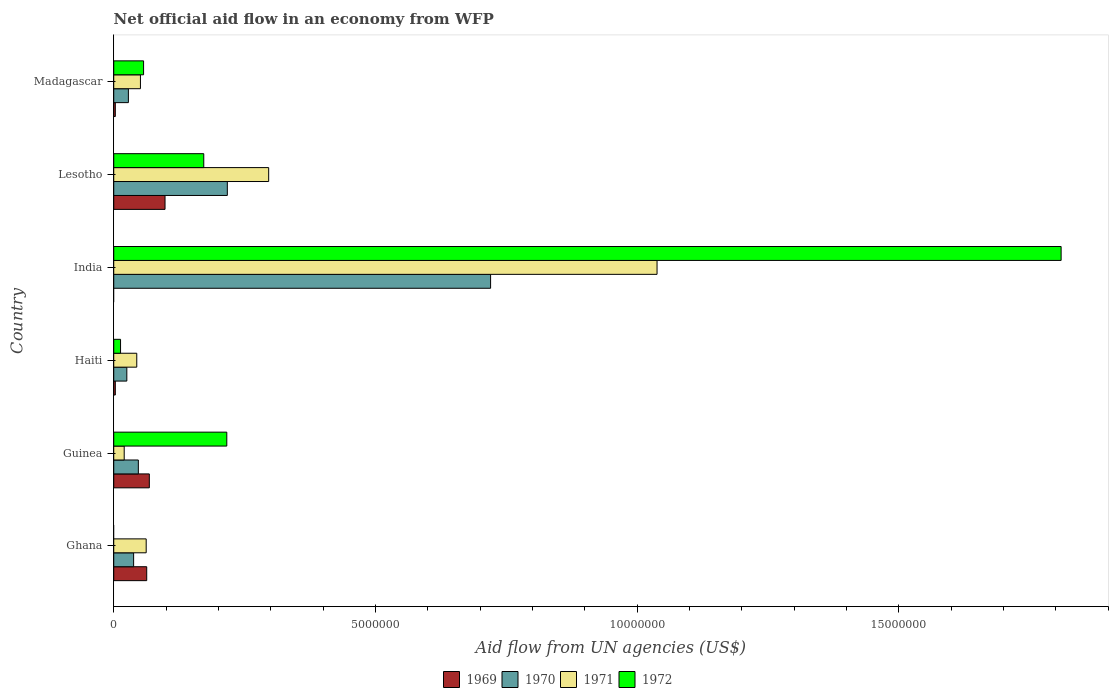How many groups of bars are there?
Offer a very short reply. 6. Are the number of bars per tick equal to the number of legend labels?
Give a very brief answer. No. How many bars are there on the 2nd tick from the top?
Your answer should be compact. 4. How many bars are there on the 3rd tick from the bottom?
Give a very brief answer. 4. What is the label of the 3rd group of bars from the top?
Provide a succinct answer. India. What is the net official aid flow in 1972 in Lesotho?
Make the answer very short. 1.72e+06. Across all countries, what is the maximum net official aid flow in 1972?
Your answer should be very brief. 1.81e+07. What is the total net official aid flow in 1971 in the graph?
Provide a short and direct response. 1.51e+07. What is the average net official aid flow in 1970 per country?
Your response must be concise. 1.79e+06. What is the difference between the net official aid flow in 1969 and net official aid flow in 1970 in Guinea?
Keep it short and to the point. 2.10e+05. In how many countries, is the net official aid flow in 1969 greater than 11000000 US$?
Your answer should be very brief. 0. What is the ratio of the net official aid flow in 1970 in Guinea to that in India?
Provide a succinct answer. 0.07. Is the difference between the net official aid flow in 1969 in Ghana and Guinea greater than the difference between the net official aid flow in 1970 in Ghana and Guinea?
Provide a short and direct response. Yes. What is the difference between the highest and the second highest net official aid flow in 1972?
Keep it short and to the point. 1.59e+07. What is the difference between the highest and the lowest net official aid flow in 1969?
Ensure brevity in your answer.  9.80e+05. How many bars are there?
Make the answer very short. 22. What is the difference between two consecutive major ticks on the X-axis?
Keep it short and to the point. 5.00e+06. Does the graph contain any zero values?
Ensure brevity in your answer.  Yes. How many legend labels are there?
Provide a short and direct response. 4. How are the legend labels stacked?
Provide a succinct answer. Horizontal. What is the title of the graph?
Give a very brief answer. Net official aid flow in an economy from WFP. What is the label or title of the X-axis?
Offer a terse response. Aid flow from UN agencies (US$). What is the Aid flow from UN agencies (US$) in 1969 in Ghana?
Your response must be concise. 6.30e+05. What is the Aid flow from UN agencies (US$) in 1970 in Ghana?
Make the answer very short. 3.80e+05. What is the Aid flow from UN agencies (US$) of 1971 in Ghana?
Your response must be concise. 6.20e+05. What is the Aid flow from UN agencies (US$) in 1972 in Ghana?
Provide a succinct answer. 0. What is the Aid flow from UN agencies (US$) of 1969 in Guinea?
Offer a very short reply. 6.80e+05. What is the Aid flow from UN agencies (US$) in 1970 in Guinea?
Your answer should be very brief. 4.70e+05. What is the Aid flow from UN agencies (US$) of 1972 in Guinea?
Your response must be concise. 2.16e+06. What is the Aid flow from UN agencies (US$) in 1969 in Haiti?
Offer a terse response. 3.00e+04. What is the Aid flow from UN agencies (US$) in 1970 in India?
Keep it short and to the point. 7.20e+06. What is the Aid flow from UN agencies (US$) in 1971 in India?
Ensure brevity in your answer.  1.04e+07. What is the Aid flow from UN agencies (US$) in 1972 in India?
Give a very brief answer. 1.81e+07. What is the Aid flow from UN agencies (US$) of 1969 in Lesotho?
Your response must be concise. 9.80e+05. What is the Aid flow from UN agencies (US$) in 1970 in Lesotho?
Offer a terse response. 2.17e+06. What is the Aid flow from UN agencies (US$) in 1971 in Lesotho?
Provide a succinct answer. 2.96e+06. What is the Aid flow from UN agencies (US$) in 1972 in Lesotho?
Give a very brief answer. 1.72e+06. What is the Aid flow from UN agencies (US$) in 1969 in Madagascar?
Make the answer very short. 3.00e+04. What is the Aid flow from UN agencies (US$) in 1971 in Madagascar?
Your answer should be very brief. 5.10e+05. What is the Aid flow from UN agencies (US$) of 1972 in Madagascar?
Keep it short and to the point. 5.70e+05. Across all countries, what is the maximum Aid flow from UN agencies (US$) of 1969?
Provide a succinct answer. 9.80e+05. Across all countries, what is the maximum Aid flow from UN agencies (US$) in 1970?
Your response must be concise. 7.20e+06. Across all countries, what is the maximum Aid flow from UN agencies (US$) in 1971?
Your answer should be very brief. 1.04e+07. Across all countries, what is the maximum Aid flow from UN agencies (US$) in 1972?
Offer a very short reply. 1.81e+07. Across all countries, what is the minimum Aid flow from UN agencies (US$) in 1969?
Ensure brevity in your answer.  0. Across all countries, what is the minimum Aid flow from UN agencies (US$) of 1970?
Make the answer very short. 2.50e+05. Across all countries, what is the minimum Aid flow from UN agencies (US$) of 1971?
Keep it short and to the point. 2.00e+05. Across all countries, what is the minimum Aid flow from UN agencies (US$) of 1972?
Your answer should be compact. 0. What is the total Aid flow from UN agencies (US$) in 1969 in the graph?
Offer a terse response. 2.35e+06. What is the total Aid flow from UN agencies (US$) in 1970 in the graph?
Offer a terse response. 1.08e+07. What is the total Aid flow from UN agencies (US$) of 1971 in the graph?
Your response must be concise. 1.51e+07. What is the total Aid flow from UN agencies (US$) of 1972 in the graph?
Ensure brevity in your answer.  2.27e+07. What is the difference between the Aid flow from UN agencies (US$) of 1969 in Ghana and that in Guinea?
Offer a very short reply. -5.00e+04. What is the difference between the Aid flow from UN agencies (US$) in 1969 in Ghana and that in Haiti?
Offer a very short reply. 6.00e+05. What is the difference between the Aid flow from UN agencies (US$) of 1970 in Ghana and that in Haiti?
Your answer should be compact. 1.30e+05. What is the difference between the Aid flow from UN agencies (US$) of 1971 in Ghana and that in Haiti?
Offer a very short reply. 1.80e+05. What is the difference between the Aid flow from UN agencies (US$) of 1970 in Ghana and that in India?
Ensure brevity in your answer.  -6.82e+06. What is the difference between the Aid flow from UN agencies (US$) in 1971 in Ghana and that in India?
Your answer should be very brief. -9.76e+06. What is the difference between the Aid flow from UN agencies (US$) of 1969 in Ghana and that in Lesotho?
Provide a short and direct response. -3.50e+05. What is the difference between the Aid flow from UN agencies (US$) in 1970 in Ghana and that in Lesotho?
Ensure brevity in your answer.  -1.79e+06. What is the difference between the Aid flow from UN agencies (US$) of 1971 in Ghana and that in Lesotho?
Your response must be concise. -2.34e+06. What is the difference between the Aid flow from UN agencies (US$) in 1969 in Guinea and that in Haiti?
Make the answer very short. 6.50e+05. What is the difference between the Aid flow from UN agencies (US$) of 1970 in Guinea and that in Haiti?
Give a very brief answer. 2.20e+05. What is the difference between the Aid flow from UN agencies (US$) of 1972 in Guinea and that in Haiti?
Your answer should be compact. 2.03e+06. What is the difference between the Aid flow from UN agencies (US$) in 1970 in Guinea and that in India?
Offer a terse response. -6.73e+06. What is the difference between the Aid flow from UN agencies (US$) of 1971 in Guinea and that in India?
Give a very brief answer. -1.02e+07. What is the difference between the Aid flow from UN agencies (US$) of 1972 in Guinea and that in India?
Your answer should be very brief. -1.59e+07. What is the difference between the Aid flow from UN agencies (US$) in 1969 in Guinea and that in Lesotho?
Keep it short and to the point. -3.00e+05. What is the difference between the Aid flow from UN agencies (US$) of 1970 in Guinea and that in Lesotho?
Your response must be concise. -1.70e+06. What is the difference between the Aid flow from UN agencies (US$) in 1971 in Guinea and that in Lesotho?
Keep it short and to the point. -2.76e+06. What is the difference between the Aid flow from UN agencies (US$) of 1969 in Guinea and that in Madagascar?
Offer a terse response. 6.50e+05. What is the difference between the Aid flow from UN agencies (US$) in 1970 in Guinea and that in Madagascar?
Provide a short and direct response. 1.90e+05. What is the difference between the Aid flow from UN agencies (US$) in 1971 in Guinea and that in Madagascar?
Your answer should be compact. -3.10e+05. What is the difference between the Aid flow from UN agencies (US$) of 1972 in Guinea and that in Madagascar?
Your response must be concise. 1.59e+06. What is the difference between the Aid flow from UN agencies (US$) of 1970 in Haiti and that in India?
Make the answer very short. -6.95e+06. What is the difference between the Aid flow from UN agencies (US$) of 1971 in Haiti and that in India?
Provide a short and direct response. -9.94e+06. What is the difference between the Aid flow from UN agencies (US$) of 1972 in Haiti and that in India?
Offer a terse response. -1.80e+07. What is the difference between the Aid flow from UN agencies (US$) in 1969 in Haiti and that in Lesotho?
Ensure brevity in your answer.  -9.50e+05. What is the difference between the Aid flow from UN agencies (US$) in 1970 in Haiti and that in Lesotho?
Your response must be concise. -1.92e+06. What is the difference between the Aid flow from UN agencies (US$) of 1971 in Haiti and that in Lesotho?
Give a very brief answer. -2.52e+06. What is the difference between the Aid flow from UN agencies (US$) of 1972 in Haiti and that in Lesotho?
Offer a very short reply. -1.59e+06. What is the difference between the Aid flow from UN agencies (US$) in 1970 in Haiti and that in Madagascar?
Offer a very short reply. -3.00e+04. What is the difference between the Aid flow from UN agencies (US$) in 1971 in Haiti and that in Madagascar?
Provide a short and direct response. -7.00e+04. What is the difference between the Aid flow from UN agencies (US$) of 1972 in Haiti and that in Madagascar?
Your response must be concise. -4.40e+05. What is the difference between the Aid flow from UN agencies (US$) in 1970 in India and that in Lesotho?
Ensure brevity in your answer.  5.03e+06. What is the difference between the Aid flow from UN agencies (US$) of 1971 in India and that in Lesotho?
Provide a short and direct response. 7.42e+06. What is the difference between the Aid flow from UN agencies (US$) in 1972 in India and that in Lesotho?
Your answer should be very brief. 1.64e+07. What is the difference between the Aid flow from UN agencies (US$) of 1970 in India and that in Madagascar?
Offer a very short reply. 6.92e+06. What is the difference between the Aid flow from UN agencies (US$) in 1971 in India and that in Madagascar?
Your answer should be very brief. 9.87e+06. What is the difference between the Aid flow from UN agencies (US$) of 1972 in India and that in Madagascar?
Provide a succinct answer. 1.75e+07. What is the difference between the Aid flow from UN agencies (US$) in 1969 in Lesotho and that in Madagascar?
Keep it short and to the point. 9.50e+05. What is the difference between the Aid flow from UN agencies (US$) of 1970 in Lesotho and that in Madagascar?
Give a very brief answer. 1.89e+06. What is the difference between the Aid flow from UN agencies (US$) in 1971 in Lesotho and that in Madagascar?
Offer a very short reply. 2.45e+06. What is the difference between the Aid flow from UN agencies (US$) in 1972 in Lesotho and that in Madagascar?
Your answer should be very brief. 1.15e+06. What is the difference between the Aid flow from UN agencies (US$) in 1969 in Ghana and the Aid flow from UN agencies (US$) in 1970 in Guinea?
Your answer should be compact. 1.60e+05. What is the difference between the Aid flow from UN agencies (US$) of 1969 in Ghana and the Aid flow from UN agencies (US$) of 1972 in Guinea?
Provide a short and direct response. -1.53e+06. What is the difference between the Aid flow from UN agencies (US$) of 1970 in Ghana and the Aid flow from UN agencies (US$) of 1972 in Guinea?
Offer a terse response. -1.78e+06. What is the difference between the Aid flow from UN agencies (US$) in 1971 in Ghana and the Aid flow from UN agencies (US$) in 1972 in Guinea?
Make the answer very short. -1.54e+06. What is the difference between the Aid flow from UN agencies (US$) of 1969 in Ghana and the Aid flow from UN agencies (US$) of 1970 in Haiti?
Offer a very short reply. 3.80e+05. What is the difference between the Aid flow from UN agencies (US$) in 1969 in Ghana and the Aid flow from UN agencies (US$) in 1972 in Haiti?
Give a very brief answer. 5.00e+05. What is the difference between the Aid flow from UN agencies (US$) of 1969 in Ghana and the Aid flow from UN agencies (US$) of 1970 in India?
Your response must be concise. -6.57e+06. What is the difference between the Aid flow from UN agencies (US$) in 1969 in Ghana and the Aid flow from UN agencies (US$) in 1971 in India?
Ensure brevity in your answer.  -9.75e+06. What is the difference between the Aid flow from UN agencies (US$) of 1969 in Ghana and the Aid flow from UN agencies (US$) of 1972 in India?
Ensure brevity in your answer.  -1.75e+07. What is the difference between the Aid flow from UN agencies (US$) in 1970 in Ghana and the Aid flow from UN agencies (US$) in 1971 in India?
Keep it short and to the point. -1.00e+07. What is the difference between the Aid flow from UN agencies (US$) of 1970 in Ghana and the Aid flow from UN agencies (US$) of 1972 in India?
Your response must be concise. -1.77e+07. What is the difference between the Aid flow from UN agencies (US$) in 1971 in Ghana and the Aid flow from UN agencies (US$) in 1972 in India?
Keep it short and to the point. -1.75e+07. What is the difference between the Aid flow from UN agencies (US$) in 1969 in Ghana and the Aid flow from UN agencies (US$) in 1970 in Lesotho?
Make the answer very short. -1.54e+06. What is the difference between the Aid flow from UN agencies (US$) in 1969 in Ghana and the Aid flow from UN agencies (US$) in 1971 in Lesotho?
Your response must be concise. -2.33e+06. What is the difference between the Aid flow from UN agencies (US$) in 1969 in Ghana and the Aid flow from UN agencies (US$) in 1972 in Lesotho?
Your answer should be very brief. -1.09e+06. What is the difference between the Aid flow from UN agencies (US$) of 1970 in Ghana and the Aid flow from UN agencies (US$) of 1971 in Lesotho?
Provide a short and direct response. -2.58e+06. What is the difference between the Aid flow from UN agencies (US$) of 1970 in Ghana and the Aid flow from UN agencies (US$) of 1972 in Lesotho?
Ensure brevity in your answer.  -1.34e+06. What is the difference between the Aid flow from UN agencies (US$) in 1971 in Ghana and the Aid flow from UN agencies (US$) in 1972 in Lesotho?
Your answer should be very brief. -1.10e+06. What is the difference between the Aid flow from UN agencies (US$) in 1969 in Ghana and the Aid flow from UN agencies (US$) in 1971 in Madagascar?
Offer a very short reply. 1.20e+05. What is the difference between the Aid flow from UN agencies (US$) in 1969 in Ghana and the Aid flow from UN agencies (US$) in 1972 in Madagascar?
Give a very brief answer. 6.00e+04. What is the difference between the Aid flow from UN agencies (US$) in 1970 in Ghana and the Aid flow from UN agencies (US$) in 1971 in Madagascar?
Offer a terse response. -1.30e+05. What is the difference between the Aid flow from UN agencies (US$) in 1970 in Ghana and the Aid flow from UN agencies (US$) in 1972 in Madagascar?
Give a very brief answer. -1.90e+05. What is the difference between the Aid flow from UN agencies (US$) in 1971 in Ghana and the Aid flow from UN agencies (US$) in 1972 in Madagascar?
Your answer should be compact. 5.00e+04. What is the difference between the Aid flow from UN agencies (US$) in 1969 in Guinea and the Aid flow from UN agencies (US$) in 1970 in Haiti?
Offer a very short reply. 4.30e+05. What is the difference between the Aid flow from UN agencies (US$) in 1969 in Guinea and the Aid flow from UN agencies (US$) in 1971 in Haiti?
Offer a terse response. 2.40e+05. What is the difference between the Aid flow from UN agencies (US$) in 1970 in Guinea and the Aid flow from UN agencies (US$) in 1971 in Haiti?
Your answer should be very brief. 3.00e+04. What is the difference between the Aid flow from UN agencies (US$) in 1970 in Guinea and the Aid flow from UN agencies (US$) in 1972 in Haiti?
Keep it short and to the point. 3.40e+05. What is the difference between the Aid flow from UN agencies (US$) in 1971 in Guinea and the Aid flow from UN agencies (US$) in 1972 in Haiti?
Your response must be concise. 7.00e+04. What is the difference between the Aid flow from UN agencies (US$) in 1969 in Guinea and the Aid flow from UN agencies (US$) in 1970 in India?
Make the answer very short. -6.52e+06. What is the difference between the Aid flow from UN agencies (US$) in 1969 in Guinea and the Aid flow from UN agencies (US$) in 1971 in India?
Keep it short and to the point. -9.70e+06. What is the difference between the Aid flow from UN agencies (US$) in 1969 in Guinea and the Aid flow from UN agencies (US$) in 1972 in India?
Your answer should be compact. -1.74e+07. What is the difference between the Aid flow from UN agencies (US$) in 1970 in Guinea and the Aid flow from UN agencies (US$) in 1971 in India?
Make the answer very short. -9.91e+06. What is the difference between the Aid flow from UN agencies (US$) in 1970 in Guinea and the Aid flow from UN agencies (US$) in 1972 in India?
Make the answer very short. -1.76e+07. What is the difference between the Aid flow from UN agencies (US$) of 1971 in Guinea and the Aid flow from UN agencies (US$) of 1972 in India?
Your response must be concise. -1.79e+07. What is the difference between the Aid flow from UN agencies (US$) of 1969 in Guinea and the Aid flow from UN agencies (US$) of 1970 in Lesotho?
Your response must be concise. -1.49e+06. What is the difference between the Aid flow from UN agencies (US$) of 1969 in Guinea and the Aid flow from UN agencies (US$) of 1971 in Lesotho?
Ensure brevity in your answer.  -2.28e+06. What is the difference between the Aid flow from UN agencies (US$) of 1969 in Guinea and the Aid flow from UN agencies (US$) of 1972 in Lesotho?
Offer a very short reply. -1.04e+06. What is the difference between the Aid flow from UN agencies (US$) of 1970 in Guinea and the Aid flow from UN agencies (US$) of 1971 in Lesotho?
Your answer should be very brief. -2.49e+06. What is the difference between the Aid flow from UN agencies (US$) in 1970 in Guinea and the Aid flow from UN agencies (US$) in 1972 in Lesotho?
Ensure brevity in your answer.  -1.25e+06. What is the difference between the Aid flow from UN agencies (US$) of 1971 in Guinea and the Aid flow from UN agencies (US$) of 1972 in Lesotho?
Offer a very short reply. -1.52e+06. What is the difference between the Aid flow from UN agencies (US$) of 1969 in Guinea and the Aid flow from UN agencies (US$) of 1970 in Madagascar?
Provide a succinct answer. 4.00e+05. What is the difference between the Aid flow from UN agencies (US$) of 1969 in Guinea and the Aid flow from UN agencies (US$) of 1972 in Madagascar?
Your response must be concise. 1.10e+05. What is the difference between the Aid flow from UN agencies (US$) in 1970 in Guinea and the Aid flow from UN agencies (US$) in 1972 in Madagascar?
Keep it short and to the point. -1.00e+05. What is the difference between the Aid flow from UN agencies (US$) in 1971 in Guinea and the Aid flow from UN agencies (US$) in 1972 in Madagascar?
Your response must be concise. -3.70e+05. What is the difference between the Aid flow from UN agencies (US$) of 1969 in Haiti and the Aid flow from UN agencies (US$) of 1970 in India?
Offer a very short reply. -7.17e+06. What is the difference between the Aid flow from UN agencies (US$) in 1969 in Haiti and the Aid flow from UN agencies (US$) in 1971 in India?
Offer a very short reply. -1.04e+07. What is the difference between the Aid flow from UN agencies (US$) in 1969 in Haiti and the Aid flow from UN agencies (US$) in 1972 in India?
Provide a short and direct response. -1.81e+07. What is the difference between the Aid flow from UN agencies (US$) in 1970 in Haiti and the Aid flow from UN agencies (US$) in 1971 in India?
Provide a short and direct response. -1.01e+07. What is the difference between the Aid flow from UN agencies (US$) in 1970 in Haiti and the Aid flow from UN agencies (US$) in 1972 in India?
Offer a terse response. -1.78e+07. What is the difference between the Aid flow from UN agencies (US$) in 1971 in Haiti and the Aid flow from UN agencies (US$) in 1972 in India?
Give a very brief answer. -1.77e+07. What is the difference between the Aid flow from UN agencies (US$) in 1969 in Haiti and the Aid flow from UN agencies (US$) in 1970 in Lesotho?
Give a very brief answer. -2.14e+06. What is the difference between the Aid flow from UN agencies (US$) of 1969 in Haiti and the Aid flow from UN agencies (US$) of 1971 in Lesotho?
Give a very brief answer. -2.93e+06. What is the difference between the Aid flow from UN agencies (US$) in 1969 in Haiti and the Aid flow from UN agencies (US$) in 1972 in Lesotho?
Provide a short and direct response. -1.69e+06. What is the difference between the Aid flow from UN agencies (US$) in 1970 in Haiti and the Aid flow from UN agencies (US$) in 1971 in Lesotho?
Offer a terse response. -2.71e+06. What is the difference between the Aid flow from UN agencies (US$) of 1970 in Haiti and the Aid flow from UN agencies (US$) of 1972 in Lesotho?
Offer a terse response. -1.47e+06. What is the difference between the Aid flow from UN agencies (US$) in 1971 in Haiti and the Aid flow from UN agencies (US$) in 1972 in Lesotho?
Your answer should be very brief. -1.28e+06. What is the difference between the Aid flow from UN agencies (US$) of 1969 in Haiti and the Aid flow from UN agencies (US$) of 1971 in Madagascar?
Your answer should be compact. -4.80e+05. What is the difference between the Aid flow from UN agencies (US$) in 1969 in Haiti and the Aid flow from UN agencies (US$) in 1972 in Madagascar?
Ensure brevity in your answer.  -5.40e+05. What is the difference between the Aid flow from UN agencies (US$) in 1970 in Haiti and the Aid flow from UN agencies (US$) in 1971 in Madagascar?
Ensure brevity in your answer.  -2.60e+05. What is the difference between the Aid flow from UN agencies (US$) of 1970 in Haiti and the Aid flow from UN agencies (US$) of 1972 in Madagascar?
Provide a succinct answer. -3.20e+05. What is the difference between the Aid flow from UN agencies (US$) of 1970 in India and the Aid flow from UN agencies (US$) of 1971 in Lesotho?
Make the answer very short. 4.24e+06. What is the difference between the Aid flow from UN agencies (US$) of 1970 in India and the Aid flow from UN agencies (US$) of 1972 in Lesotho?
Provide a short and direct response. 5.48e+06. What is the difference between the Aid flow from UN agencies (US$) in 1971 in India and the Aid flow from UN agencies (US$) in 1972 in Lesotho?
Your answer should be very brief. 8.66e+06. What is the difference between the Aid flow from UN agencies (US$) of 1970 in India and the Aid flow from UN agencies (US$) of 1971 in Madagascar?
Give a very brief answer. 6.69e+06. What is the difference between the Aid flow from UN agencies (US$) of 1970 in India and the Aid flow from UN agencies (US$) of 1972 in Madagascar?
Your answer should be compact. 6.63e+06. What is the difference between the Aid flow from UN agencies (US$) of 1971 in India and the Aid flow from UN agencies (US$) of 1972 in Madagascar?
Keep it short and to the point. 9.81e+06. What is the difference between the Aid flow from UN agencies (US$) of 1969 in Lesotho and the Aid flow from UN agencies (US$) of 1971 in Madagascar?
Provide a succinct answer. 4.70e+05. What is the difference between the Aid flow from UN agencies (US$) in 1970 in Lesotho and the Aid flow from UN agencies (US$) in 1971 in Madagascar?
Offer a terse response. 1.66e+06. What is the difference between the Aid flow from UN agencies (US$) of 1970 in Lesotho and the Aid flow from UN agencies (US$) of 1972 in Madagascar?
Your answer should be compact. 1.60e+06. What is the difference between the Aid flow from UN agencies (US$) in 1971 in Lesotho and the Aid flow from UN agencies (US$) in 1972 in Madagascar?
Provide a succinct answer. 2.39e+06. What is the average Aid flow from UN agencies (US$) of 1969 per country?
Offer a terse response. 3.92e+05. What is the average Aid flow from UN agencies (US$) of 1970 per country?
Ensure brevity in your answer.  1.79e+06. What is the average Aid flow from UN agencies (US$) of 1971 per country?
Offer a terse response. 2.52e+06. What is the average Aid flow from UN agencies (US$) in 1972 per country?
Offer a very short reply. 3.78e+06. What is the difference between the Aid flow from UN agencies (US$) of 1970 and Aid flow from UN agencies (US$) of 1971 in Ghana?
Your response must be concise. -2.40e+05. What is the difference between the Aid flow from UN agencies (US$) of 1969 and Aid flow from UN agencies (US$) of 1970 in Guinea?
Keep it short and to the point. 2.10e+05. What is the difference between the Aid flow from UN agencies (US$) of 1969 and Aid flow from UN agencies (US$) of 1972 in Guinea?
Provide a short and direct response. -1.48e+06. What is the difference between the Aid flow from UN agencies (US$) in 1970 and Aid flow from UN agencies (US$) in 1971 in Guinea?
Provide a short and direct response. 2.70e+05. What is the difference between the Aid flow from UN agencies (US$) of 1970 and Aid flow from UN agencies (US$) of 1972 in Guinea?
Your response must be concise. -1.69e+06. What is the difference between the Aid flow from UN agencies (US$) in 1971 and Aid flow from UN agencies (US$) in 1972 in Guinea?
Your answer should be very brief. -1.96e+06. What is the difference between the Aid flow from UN agencies (US$) in 1969 and Aid flow from UN agencies (US$) in 1970 in Haiti?
Make the answer very short. -2.20e+05. What is the difference between the Aid flow from UN agencies (US$) in 1969 and Aid flow from UN agencies (US$) in 1971 in Haiti?
Offer a very short reply. -4.10e+05. What is the difference between the Aid flow from UN agencies (US$) of 1971 and Aid flow from UN agencies (US$) of 1972 in Haiti?
Keep it short and to the point. 3.10e+05. What is the difference between the Aid flow from UN agencies (US$) of 1970 and Aid flow from UN agencies (US$) of 1971 in India?
Give a very brief answer. -3.18e+06. What is the difference between the Aid flow from UN agencies (US$) in 1970 and Aid flow from UN agencies (US$) in 1972 in India?
Keep it short and to the point. -1.09e+07. What is the difference between the Aid flow from UN agencies (US$) of 1971 and Aid flow from UN agencies (US$) of 1972 in India?
Keep it short and to the point. -7.72e+06. What is the difference between the Aid flow from UN agencies (US$) of 1969 and Aid flow from UN agencies (US$) of 1970 in Lesotho?
Make the answer very short. -1.19e+06. What is the difference between the Aid flow from UN agencies (US$) of 1969 and Aid flow from UN agencies (US$) of 1971 in Lesotho?
Give a very brief answer. -1.98e+06. What is the difference between the Aid flow from UN agencies (US$) in 1969 and Aid flow from UN agencies (US$) in 1972 in Lesotho?
Give a very brief answer. -7.40e+05. What is the difference between the Aid flow from UN agencies (US$) in 1970 and Aid flow from UN agencies (US$) in 1971 in Lesotho?
Your response must be concise. -7.90e+05. What is the difference between the Aid flow from UN agencies (US$) in 1971 and Aid flow from UN agencies (US$) in 1972 in Lesotho?
Ensure brevity in your answer.  1.24e+06. What is the difference between the Aid flow from UN agencies (US$) in 1969 and Aid flow from UN agencies (US$) in 1970 in Madagascar?
Keep it short and to the point. -2.50e+05. What is the difference between the Aid flow from UN agencies (US$) of 1969 and Aid flow from UN agencies (US$) of 1971 in Madagascar?
Your answer should be very brief. -4.80e+05. What is the difference between the Aid flow from UN agencies (US$) in 1969 and Aid flow from UN agencies (US$) in 1972 in Madagascar?
Give a very brief answer. -5.40e+05. What is the difference between the Aid flow from UN agencies (US$) in 1970 and Aid flow from UN agencies (US$) in 1971 in Madagascar?
Your answer should be compact. -2.30e+05. What is the ratio of the Aid flow from UN agencies (US$) in 1969 in Ghana to that in Guinea?
Your answer should be compact. 0.93. What is the ratio of the Aid flow from UN agencies (US$) of 1970 in Ghana to that in Guinea?
Provide a succinct answer. 0.81. What is the ratio of the Aid flow from UN agencies (US$) in 1969 in Ghana to that in Haiti?
Ensure brevity in your answer.  21. What is the ratio of the Aid flow from UN agencies (US$) of 1970 in Ghana to that in Haiti?
Make the answer very short. 1.52. What is the ratio of the Aid flow from UN agencies (US$) in 1971 in Ghana to that in Haiti?
Offer a very short reply. 1.41. What is the ratio of the Aid flow from UN agencies (US$) of 1970 in Ghana to that in India?
Keep it short and to the point. 0.05. What is the ratio of the Aid flow from UN agencies (US$) of 1971 in Ghana to that in India?
Keep it short and to the point. 0.06. What is the ratio of the Aid flow from UN agencies (US$) of 1969 in Ghana to that in Lesotho?
Offer a terse response. 0.64. What is the ratio of the Aid flow from UN agencies (US$) in 1970 in Ghana to that in Lesotho?
Keep it short and to the point. 0.18. What is the ratio of the Aid flow from UN agencies (US$) of 1971 in Ghana to that in Lesotho?
Your response must be concise. 0.21. What is the ratio of the Aid flow from UN agencies (US$) of 1970 in Ghana to that in Madagascar?
Your answer should be very brief. 1.36. What is the ratio of the Aid flow from UN agencies (US$) in 1971 in Ghana to that in Madagascar?
Ensure brevity in your answer.  1.22. What is the ratio of the Aid flow from UN agencies (US$) of 1969 in Guinea to that in Haiti?
Ensure brevity in your answer.  22.67. What is the ratio of the Aid flow from UN agencies (US$) of 1970 in Guinea to that in Haiti?
Your answer should be compact. 1.88. What is the ratio of the Aid flow from UN agencies (US$) of 1971 in Guinea to that in Haiti?
Give a very brief answer. 0.45. What is the ratio of the Aid flow from UN agencies (US$) of 1972 in Guinea to that in Haiti?
Provide a succinct answer. 16.62. What is the ratio of the Aid flow from UN agencies (US$) of 1970 in Guinea to that in India?
Make the answer very short. 0.07. What is the ratio of the Aid flow from UN agencies (US$) of 1971 in Guinea to that in India?
Give a very brief answer. 0.02. What is the ratio of the Aid flow from UN agencies (US$) of 1972 in Guinea to that in India?
Your answer should be compact. 0.12. What is the ratio of the Aid flow from UN agencies (US$) in 1969 in Guinea to that in Lesotho?
Your response must be concise. 0.69. What is the ratio of the Aid flow from UN agencies (US$) of 1970 in Guinea to that in Lesotho?
Your answer should be compact. 0.22. What is the ratio of the Aid flow from UN agencies (US$) in 1971 in Guinea to that in Lesotho?
Offer a terse response. 0.07. What is the ratio of the Aid flow from UN agencies (US$) in 1972 in Guinea to that in Lesotho?
Ensure brevity in your answer.  1.26. What is the ratio of the Aid flow from UN agencies (US$) in 1969 in Guinea to that in Madagascar?
Give a very brief answer. 22.67. What is the ratio of the Aid flow from UN agencies (US$) in 1970 in Guinea to that in Madagascar?
Your answer should be very brief. 1.68. What is the ratio of the Aid flow from UN agencies (US$) in 1971 in Guinea to that in Madagascar?
Give a very brief answer. 0.39. What is the ratio of the Aid flow from UN agencies (US$) of 1972 in Guinea to that in Madagascar?
Your answer should be very brief. 3.79. What is the ratio of the Aid flow from UN agencies (US$) in 1970 in Haiti to that in India?
Your response must be concise. 0.03. What is the ratio of the Aid flow from UN agencies (US$) of 1971 in Haiti to that in India?
Your response must be concise. 0.04. What is the ratio of the Aid flow from UN agencies (US$) in 1972 in Haiti to that in India?
Give a very brief answer. 0.01. What is the ratio of the Aid flow from UN agencies (US$) of 1969 in Haiti to that in Lesotho?
Provide a succinct answer. 0.03. What is the ratio of the Aid flow from UN agencies (US$) of 1970 in Haiti to that in Lesotho?
Keep it short and to the point. 0.12. What is the ratio of the Aid flow from UN agencies (US$) of 1971 in Haiti to that in Lesotho?
Give a very brief answer. 0.15. What is the ratio of the Aid flow from UN agencies (US$) in 1972 in Haiti to that in Lesotho?
Your response must be concise. 0.08. What is the ratio of the Aid flow from UN agencies (US$) of 1970 in Haiti to that in Madagascar?
Provide a succinct answer. 0.89. What is the ratio of the Aid flow from UN agencies (US$) in 1971 in Haiti to that in Madagascar?
Offer a very short reply. 0.86. What is the ratio of the Aid flow from UN agencies (US$) in 1972 in Haiti to that in Madagascar?
Make the answer very short. 0.23. What is the ratio of the Aid flow from UN agencies (US$) in 1970 in India to that in Lesotho?
Provide a succinct answer. 3.32. What is the ratio of the Aid flow from UN agencies (US$) of 1971 in India to that in Lesotho?
Keep it short and to the point. 3.51. What is the ratio of the Aid flow from UN agencies (US$) in 1972 in India to that in Lesotho?
Give a very brief answer. 10.52. What is the ratio of the Aid flow from UN agencies (US$) of 1970 in India to that in Madagascar?
Offer a terse response. 25.71. What is the ratio of the Aid flow from UN agencies (US$) of 1971 in India to that in Madagascar?
Your answer should be compact. 20.35. What is the ratio of the Aid flow from UN agencies (US$) in 1972 in India to that in Madagascar?
Your response must be concise. 31.75. What is the ratio of the Aid flow from UN agencies (US$) in 1969 in Lesotho to that in Madagascar?
Give a very brief answer. 32.67. What is the ratio of the Aid flow from UN agencies (US$) of 1970 in Lesotho to that in Madagascar?
Offer a terse response. 7.75. What is the ratio of the Aid flow from UN agencies (US$) of 1971 in Lesotho to that in Madagascar?
Your answer should be very brief. 5.8. What is the ratio of the Aid flow from UN agencies (US$) of 1972 in Lesotho to that in Madagascar?
Keep it short and to the point. 3.02. What is the difference between the highest and the second highest Aid flow from UN agencies (US$) in 1970?
Provide a succinct answer. 5.03e+06. What is the difference between the highest and the second highest Aid flow from UN agencies (US$) in 1971?
Your answer should be very brief. 7.42e+06. What is the difference between the highest and the second highest Aid flow from UN agencies (US$) in 1972?
Your response must be concise. 1.59e+07. What is the difference between the highest and the lowest Aid flow from UN agencies (US$) in 1969?
Ensure brevity in your answer.  9.80e+05. What is the difference between the highest and the lowest Aid flow from UN agencies (US$) in 1970?
Ensure brevity in your answer.  6.95e+06. What is the difference between the highest and the lowest Aid flow from UN agencies (US$) in 1971?
Provide a short and direct response. 1.02e+07. What is the difference between the highest and the lowest Aid flow from UN agencies (US$) in 1972?
Provide a succinct answer. 1.81e+07. 